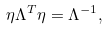Convert formula to latex. <formula><loc_0><loc_0><loc_500><loc_500>\eta \Lambda ^ { T } \eta = \Lambda ^ { - 1 } ,</formula> 